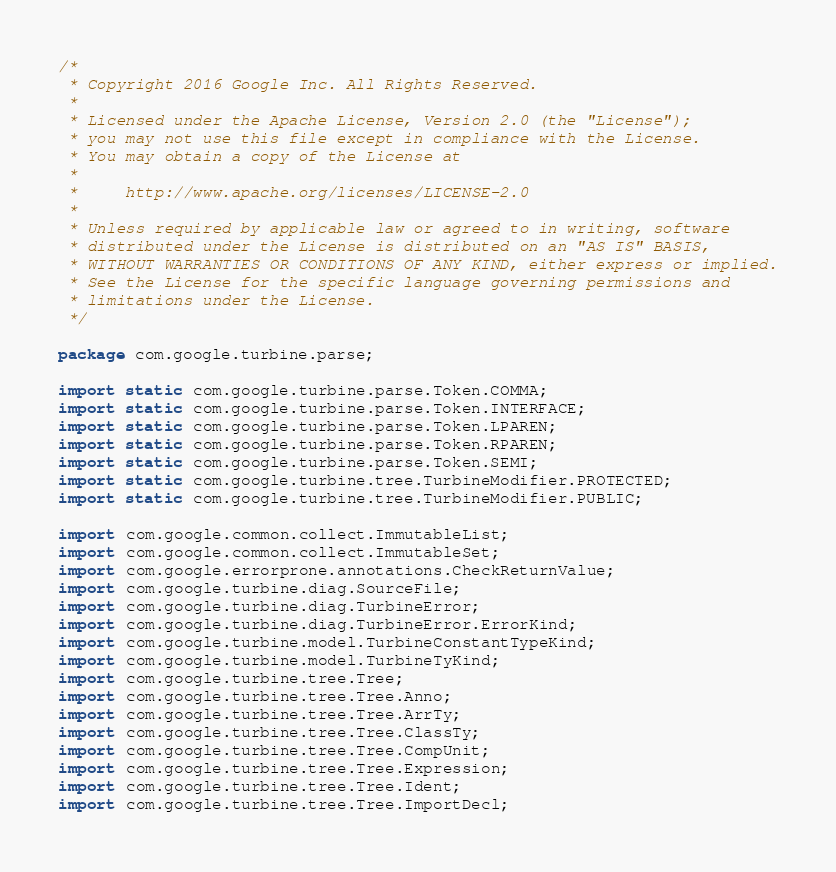<code> <loc_0><loc_0><loc_500><loc_500><_Java_>/*
 * Copyright 2016 Google Inc. All Rights Reserved.
 *
 * Licensed under the Apache License, Version 2.0 (the "License");
 * you may not use this file except in compliance with the License.
 * You may obtain a copy of the License at
 *
 *     http://www.apache.org/licenses/LICENSE-2.0
 *
 * Unless required by applicable law or agreed to in writing, software
 * distributed under the License is distributed on an "AS IS" BASIS,
 * WITHOUT WARRANTIES OR CONDITIONS OF ANY KIND, either express or implied.
 * See the License for the specific language governing permissions and
 * limitations under the License.
 */

package com.google.turbine.parse;

import static com.google.turbine.parse.Token.COMMA;
import static com.google.turbine.parse.Token.INTERFACE;
import static com.google.turbine.parse.Token.LPAREN;
import static com.google.turbine.parse.Token.RPAREN;
import static com.google.turbine.parse.Token.SEMI;
import static com.google.turbine.tree.TurbineModifier.PROTECTED;
import static com.google.turbine.tree.TurbineModifier.PUBLIC;

import com.google.common.collect.ImmutableList;
import com.google.common.collect.ImmutableSet;
import com.google.errorprone.annotations.CheckReturnValue;
import com.google.turbine.diag.SourceFile;
import com.google.turbine.diag.TurbineError;
import com.google.turbine.diag.TurbineError.ErrorKind;
import com.google.turbine.model.TurbineConstantTypeKind;
import com.google.turbine.model.TurbineTyKind;
import com.google.turbine.tree.Tree;
import com.google.turbine.tree.Tree.Anno;
import com.google.turbine.tree.Tree.ArrTy;
import com.google.turbine.tree.Tree.ClassTy;
import com.google.turbine.tree.Tree.CompUnit;
import com.google.turbine.tree.Tree.Expression;
import com.google.turbine.tree.Tree.Ident;
import com.google.turbine.tree.Tree.ImportDecl;</code> 